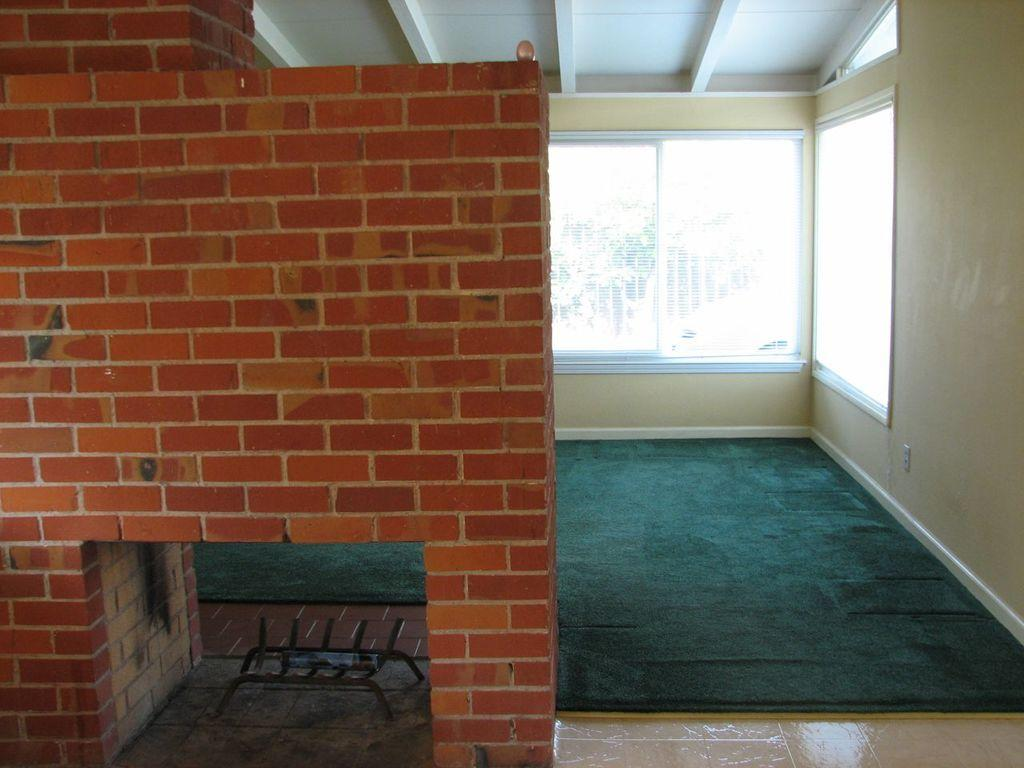What type of space is depicted in the image? The image shows an inside view of a hall. What can be seen on the front wall of the hall? There is a brown color brick wall in the front. What is located behind the brick wall? There is a glass window behind the brick wall. What color is the wall behind the glass window? The wall behind the glass window is yellow in color. How many kites are hanging from the ceiling in the image? There are no kites present in the image. What type of knowledge is being shared in the hall in the image? The image does not provide any information about knowledge being shared in the hall. 